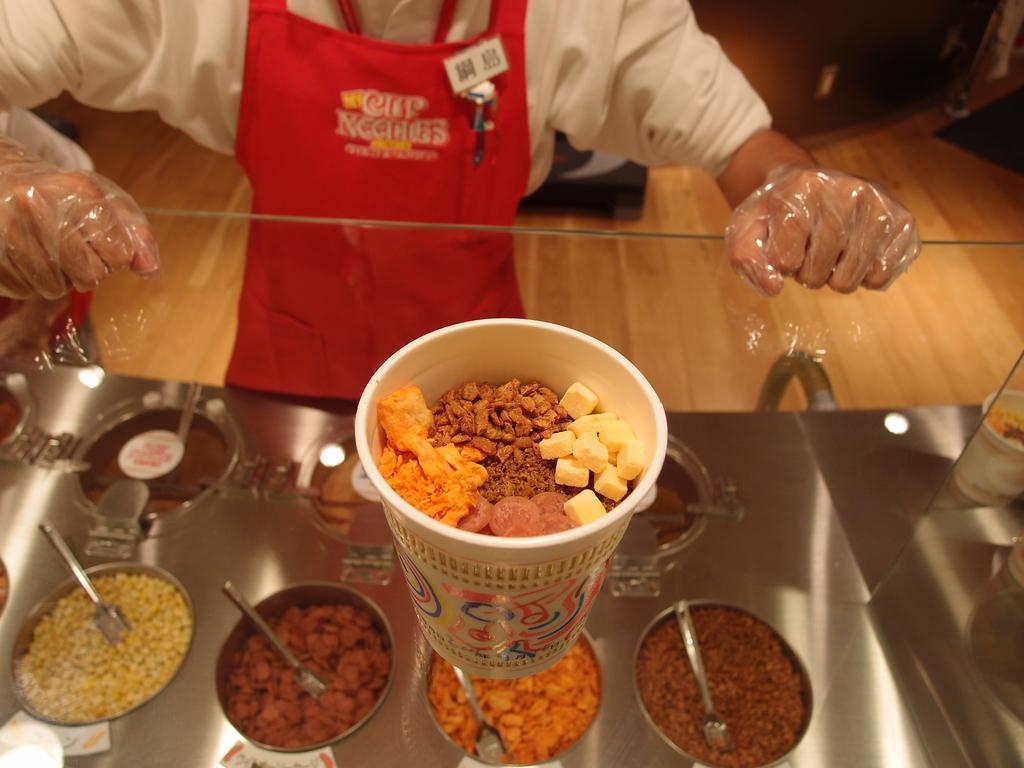Could you give a brief overview of what you see in this image? In the center of the image a cup of food is present on the glass. At the bottom of the image we can see a food items are present in a container and spoon is there. At the top of the image a person is standing. In the middle of the image floor is there. At the top of the image wall is present. 